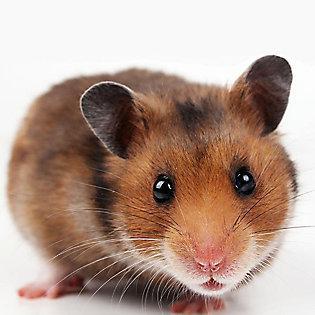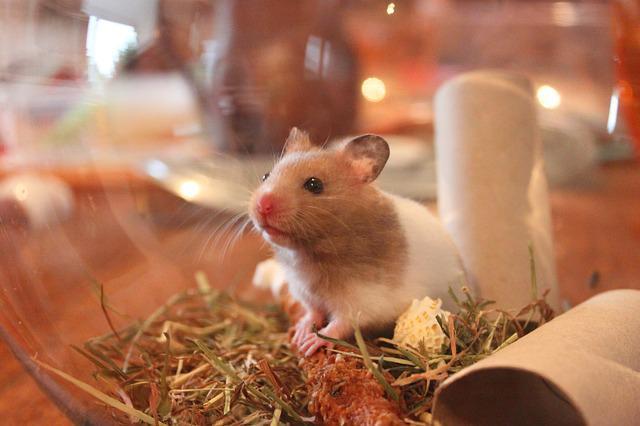The first image is the image on the left, the second image is the image on the right. Examine the images to the left and right. Is the description "There is a hamster eating a carrot." accurate? Answer yes or no. No. 